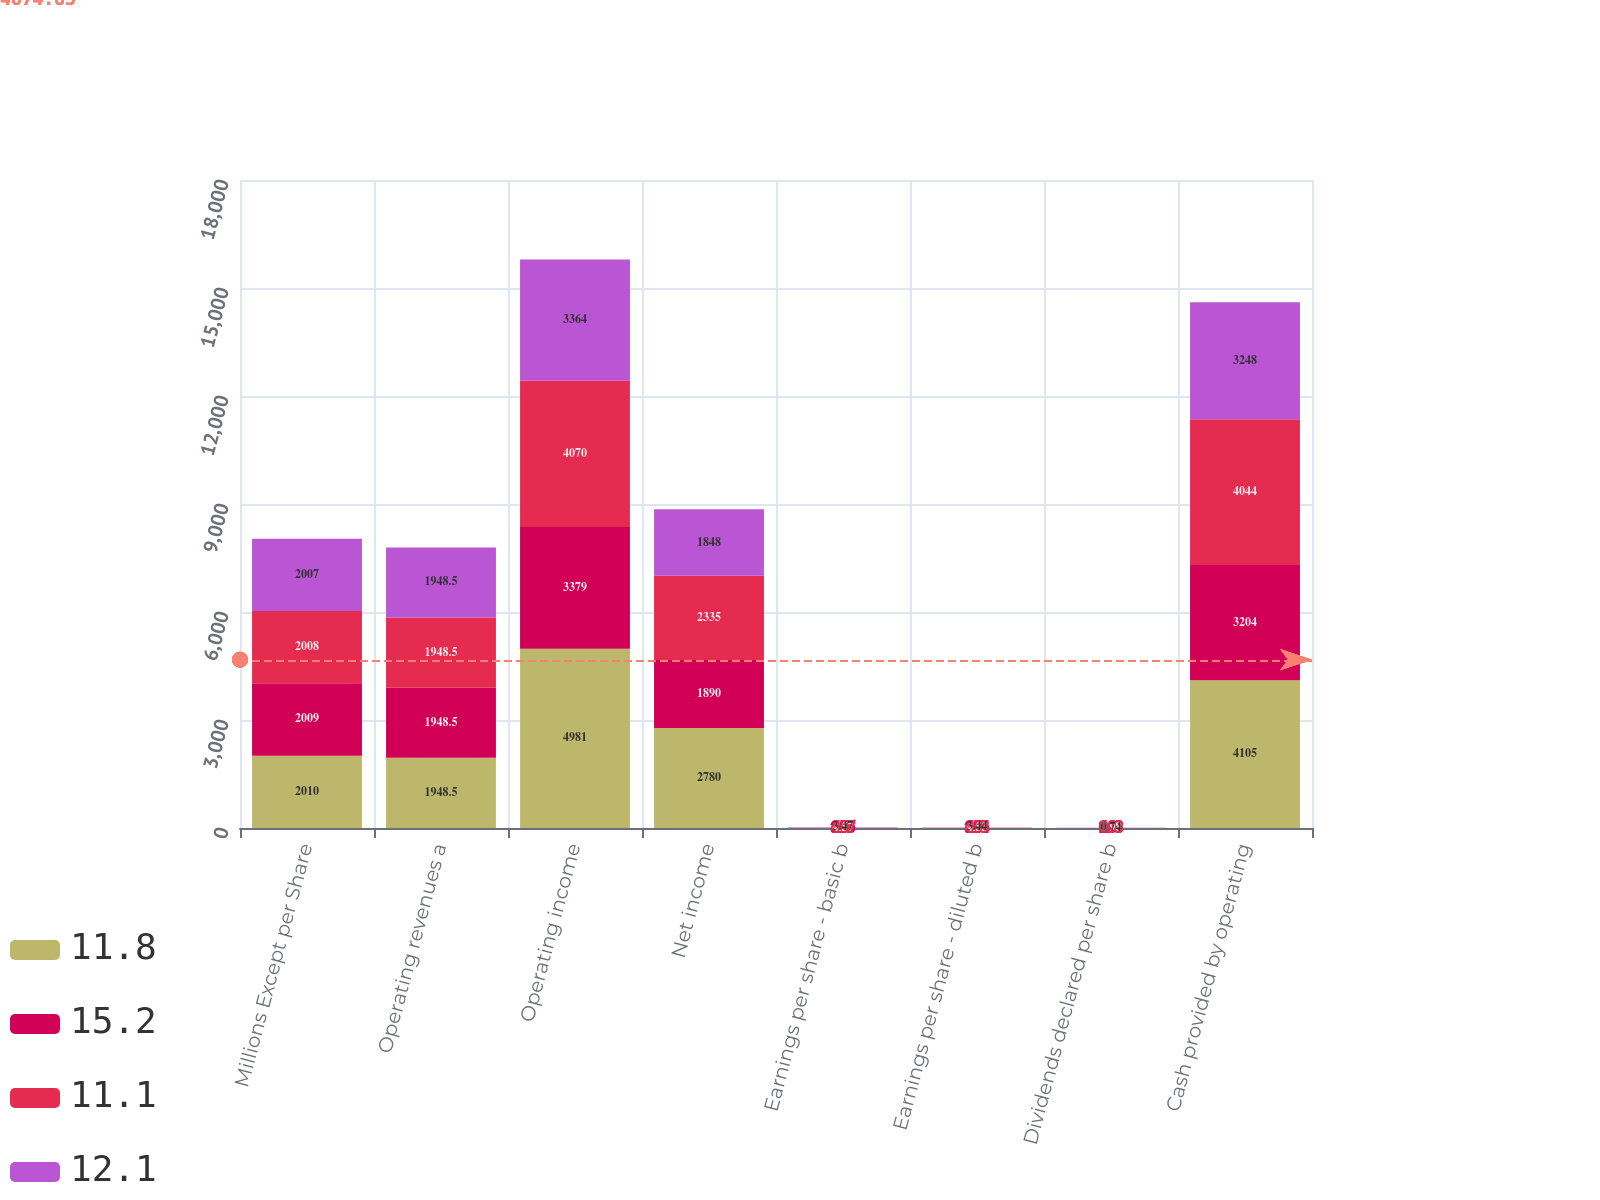Convert chart to OTSL. <chart><loc_0><loc_0><loc_500><loc_500><stacked_bar_chart><ecel><fcel>Millions Except per Share<fcel>Operating revenues a<fcel>Operating income<fcel>Net income<fcel>Earnings per share - basic b<fcel>Earnings per share - diluted b<fcel>Dividends declared per share b<fcel>Cash provided by operating<nl><fcel>11.8<fcel>2010<fcel>1948.5<fcel>4981<fcel>2780<fcel>5.58<fcel>5.53<fcel>1.31<fcel>4105<nl><fcel>15.2<fcel>2009<fcel>1948.5<fcel>3379<fcel>1890<fcel>3.76<fcel>3.74<fcel>1.08<fcel>3204<nl><fcel>11.1<fcel>2008<fcel>1948.5<fcel>4070<fcel>2335<fcel>4.57<fcel>4.53<fcel>0.98<fcel>4044<nl><fcel>12.1<fcel>2007<fcel>1948.5<fcel>3364<fcel>1848<fcel>3.47<fcel>3.44<fcel>0.74<fcel>3248<nl></chart> 